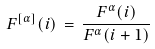<formula> <loc_0><loc_0><loc_500><loc_500>F ^ { [ \alpha ] } ( i ) \, = \, \frac { F ^ { \alpha } ( i ) } { F ^ { \alpha } ( i + 1 ) }</formula> 